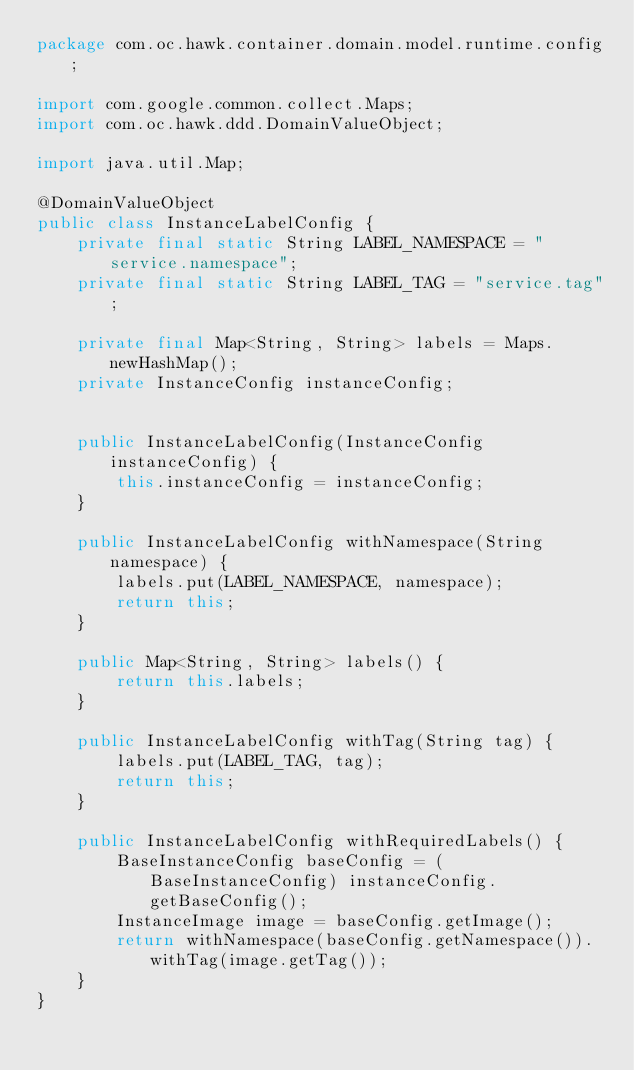<code> <loc_0><loc_0><loc_500><loc_500><_Java_>package com.oc.hawk.container.domain.model.runtime.config;

import com.google.common.collect.Maps;
import com.oc.hawk.ddd.DomainValueObject;

import java.util.Map;

@DomainValueObject
public class InstanceLabelConfig {
    private final static String LABEL_NAMESPACE = "service.namespace";
    private final static String LABEL_TAG = "service.tag";

    private final Map<String, String> labels = Maps.newHashMap();
    private InstanceConfig instanceConfig;


    public InstanceLabelConfig(InstanceConfig instanceConfig) {
        this.instanceConfig = instanceConfig;
    }

    public InstanceLabelConfig withNamespace(String namespace) {
        labels.put(LABEL_NAMESPACE, namespace);
        return this;
    }

    public Map<String, String> labels() {
        return this.labels;
    }

    public InstanceLabelConfig withTag(String tag) {
        labels.put(LABEL_TAG, tag);
        return this;
    }

    public InstanceLabelConfig withRequiredLabels() {
        BaseInstanceConfig baseConfig = (BaseInstanceConfig) instanceConfig.getBaseConfig();
        InstanceImage image = baseConfig.getImage();
        return withNamespace(baseConfig.getNamespace()).withTag(image.getTag());
    }
}
</code> 